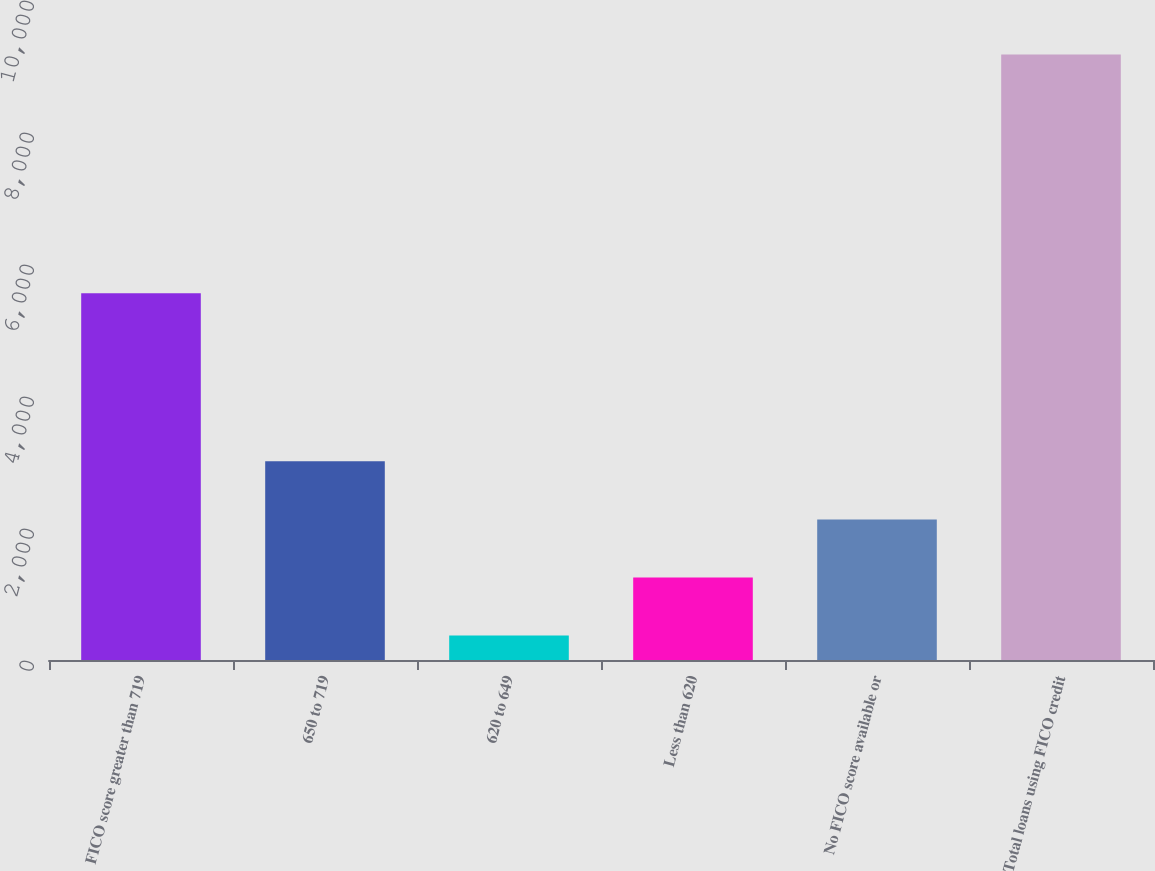Convert chart to OTSL. <chart><loc_0><loc_0><loc_500><loc_500><bar_chart><fcel>FICO score greater than 719<fcel>650 to 719<fcel>620 to 649<fcel>Less than 620<fcel>No FICO score available or<fcel>Total loans using FICO credit<nl><fcel>5556<fcel>3010.9<fcel>370<fcel>1250.3<fcel>2130.6<fcel>9173<nl></chart> 